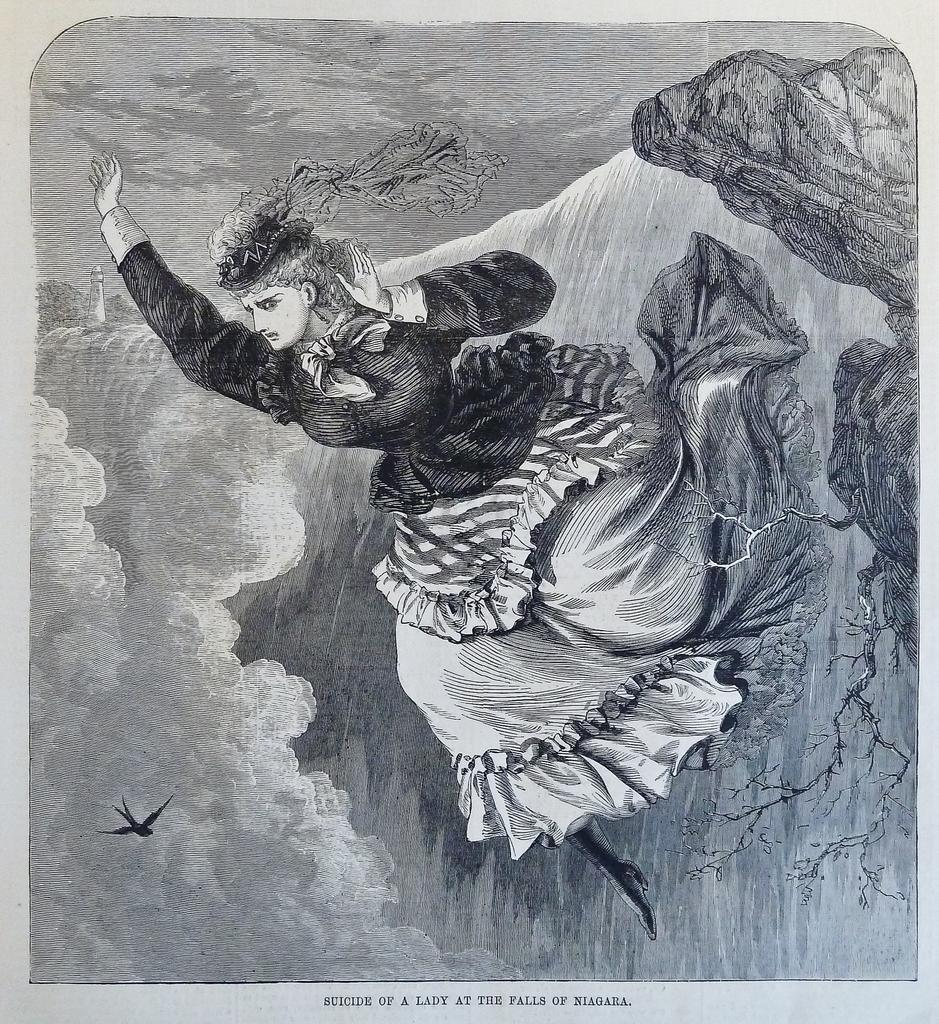What is the main subject of the image? The main subject of the image is an art piece. What else can be seen in the image besides the art piece? There is text in the image. What type of tramp is depicted in the art piece in the image? There is no tramp depicted in the art piece in the image. What kind of instrument is being played by the musician in the image? There is no musician or instrument present in the image. 